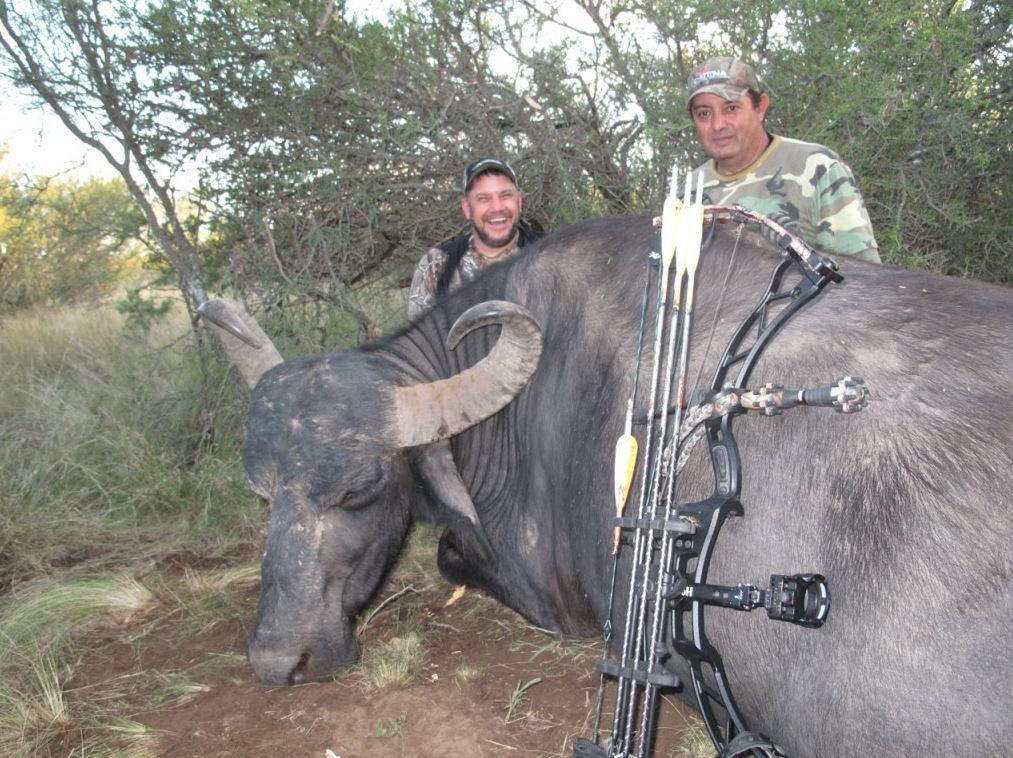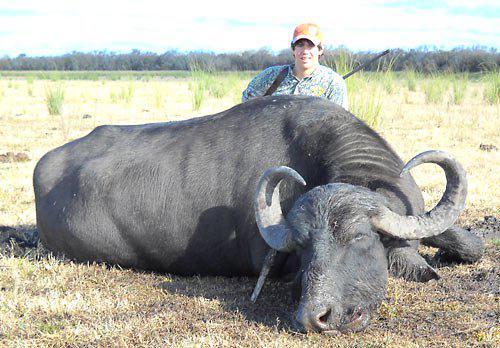The first image is the image on the left, the second image is the image on the right. For the images displayed, is the sentence "The left image contains three humans posing with a dead water buffalo." factually correct? Answer yes or no. No. The first image is the image on the left, the second image is the image on the right. Considering the images on both sides, is "Three hunters with one gun pose behind a downed water buffalo in one image, and one man poses with his weapon and a dead water buffalo in the other image." valid? Answer yes or no. No. 